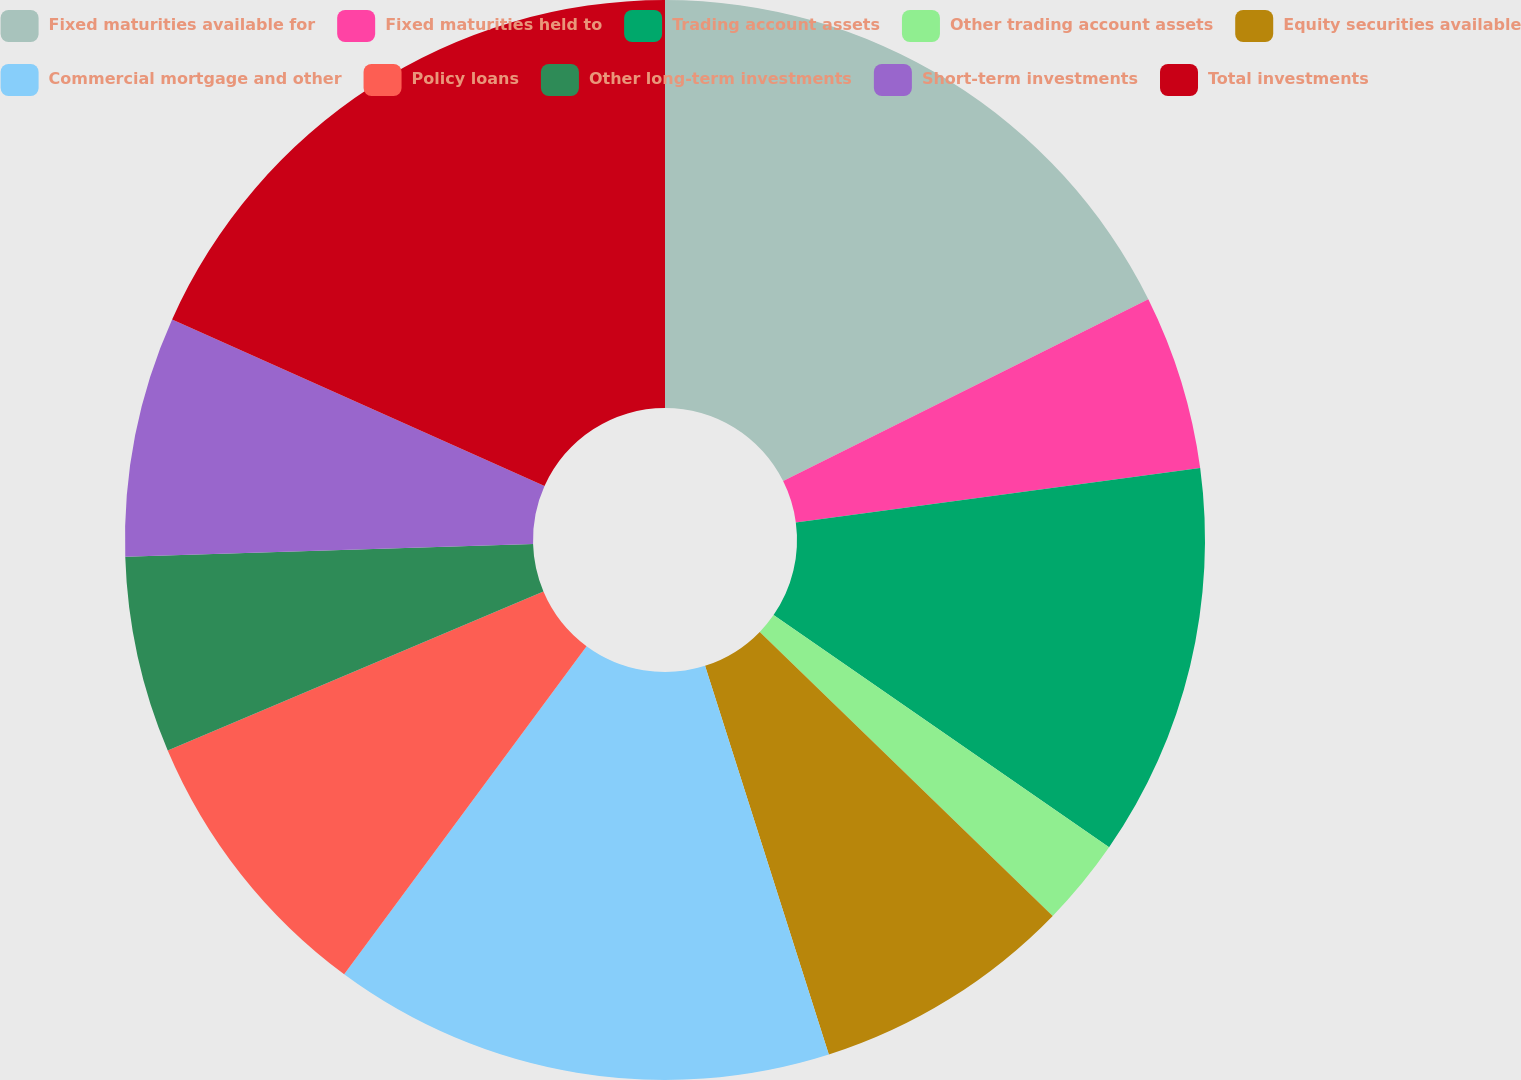Convert chart to OTSL. <chart><loc_0><loc_0><loc_500><loc_500><pie_chart><fcel>Fixed maturities available for<fcel>Fixed maturities held to<fcel>Trading account assets<fcel>Other trading account assets<fcel>Equity securities available<fcel>Commercial mortgage and other<fcel>Policy loans<fcel>Other long-term investments<fcel>Short-term investments<fcel>Total investments<nl><fcel>17.64%<fcel>5.23%<fcel>11.76%<fcel>2.62%<fcel>7.84%<fcel>15.03%<fcel>8.5%<fcel>5.88%<fcel>7.19%<fcel>18.3%<nl></chart> 